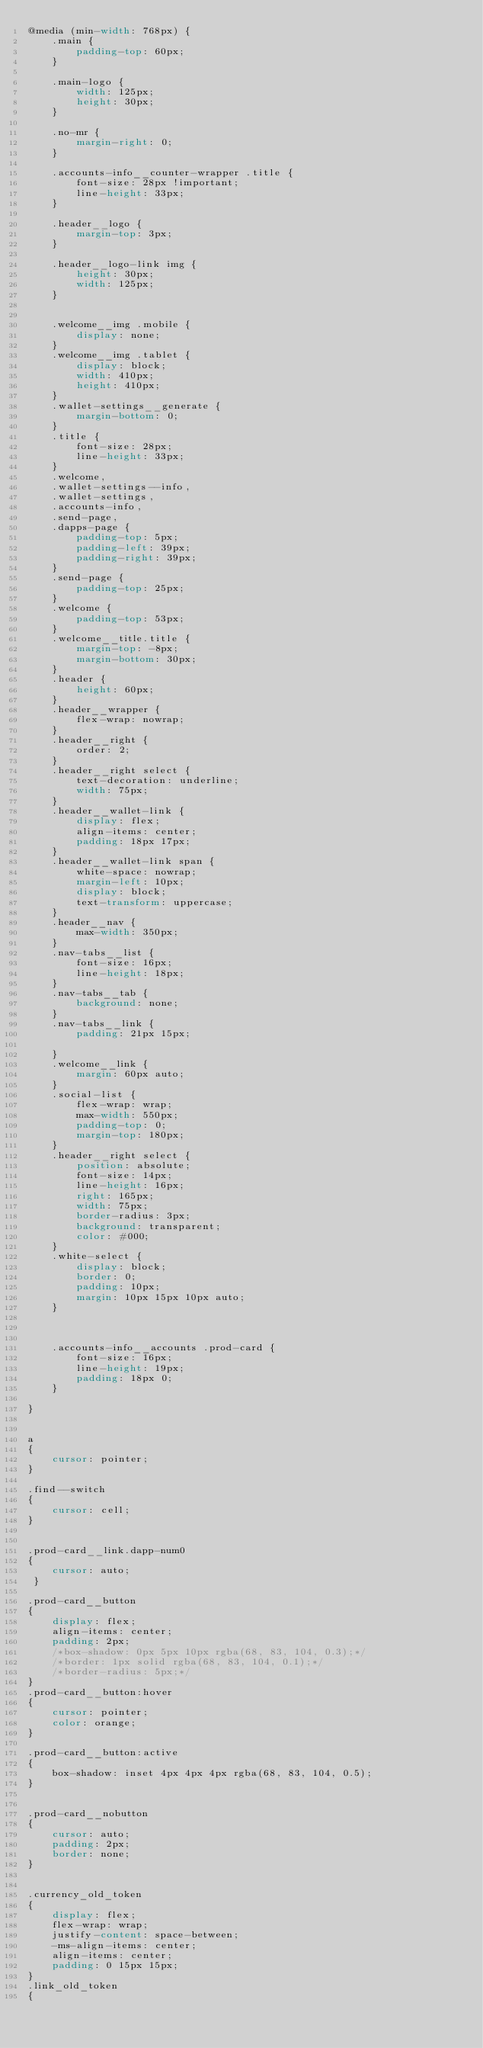<code> <loc_0><loc_0><loc_500><loc_500><_CSS_>@media (min-width: 768px) {
    .main {
        padding-top: 60px;
    }

    .main-logo {
        width: 125px;
        height: 30px;
    }

    .no-mr {
        margin-right: 0;
    }

    .accounts-info__counter-wrapper .title {
        font-size: 28px !important;
        line-height: 33px;
    }

    .header__logo {
        margin-top: 3px;
    }

    .header__logo-link img {
        height: 30px;
        width: 125px;
    }


    .welcome__img .mobile {
        display: none;
    }
    .welcome__img .tablet {
        display: block;
        width: 410px;
        height: 410px;
    }
    .wallet-settings__generate {
        margin-bottom: 0;
    }
    .title {
        font-size: 28px;
        line-height: 33px;
    }
    .welcome,
    .wallet-settings--info,
    .wallet-settings,
    .accounts-info,
    .send-page,
    .dapps-page {
        padding-top: 5px;
        padding-left: 39px;
        padding-right: 39px;
    }
    .send-page {
        padding-top: 25px;
    }
    .welcome {
        padding-top: 53px;
    }
    .welcome__title.title {
        margin-top: -8px;
        margin-bottom: 30px;
    }
    .header {
        height: 60px;
    }
    .header__wrapper {
        flex-wrap: nowrap;
    }
    .header__right {
        order: 2;
    }
    .header__right select {
        text-decoration: underline;
        width: 75px;
    }
    .header__wallet-link {
        display: flex;
        align-items: center;
        padding: 18px 17px;
    }
    .header__wallet-link span {
        white-space: nowrap;
        margin-left: 10px;
        display: block;
        text-transform: uppercase;
    }
    .header__nav {
        max-width: 350px;
    }
    .nav-tabs__list {
        font-size: 16px;
        line-height: 18px;
    }
    .nav-tabs__tab {
        background: none;
    }
    .nav-tabs__link {
        padding: 21px 15px;

    }
    .welcome__link {
        margin: 60px auto;
    }
    .social-list {
        flex-wrap: wrap;
        max-width: 550px;
        padding-top: 0;
        margin-top: 180px;
    }
    .header__right select {
        position: absolute;
        font-size: 14px;
        line-height: 16px;
        right: 165px;
        width: 75px;
        border-radius: 3px;
        background: transparent;
        color: #000;
    }
    .white-select {
        display: block;
        border: 0;
        padding: 10px;
        margin: 10px 15px 10px auto;
    }



    .accounts-info__accounts .prod-card {
        font-size: 16px;
        line-height: 19px;
        padding: 18px 0;
    }

}


a
{
    cursor: pointer;
}

.find--switch
{
    cursor: cell;
}


.prod-card__link.dapp-num0
{
    cursor: auto;
 }

.prod-card__button
{
    display: flex;
    align-items: center;
    padding: 2px;
    /*box-shadow: 0px 5px 10px rgba(68, 83, 104, 0.3);*/
    /*border: 1px solid rgba(68, 83, 104, 0.1);*/
    /*border-radius: 5px;*/
}
.prod-card__button:hover
{
    cursor: pointer;
    color: orange;
}

.prod-card__button:active
{
    box-shadow: inset 4px 4px 4px rgba(68, 83, 104, 0.5);
}


.prod-card__nobutton
{
    cursor: auto;
    padding: 2px;
    border: none;
}


.currency_old_token
{
    display: flex;
    flex-wrap: wrap;
    justify-content: space-between;
    -ms-align-items: center;
    align-items: center;
    padding: 0 15px 15px;
}
.link_old_token
{</code> 